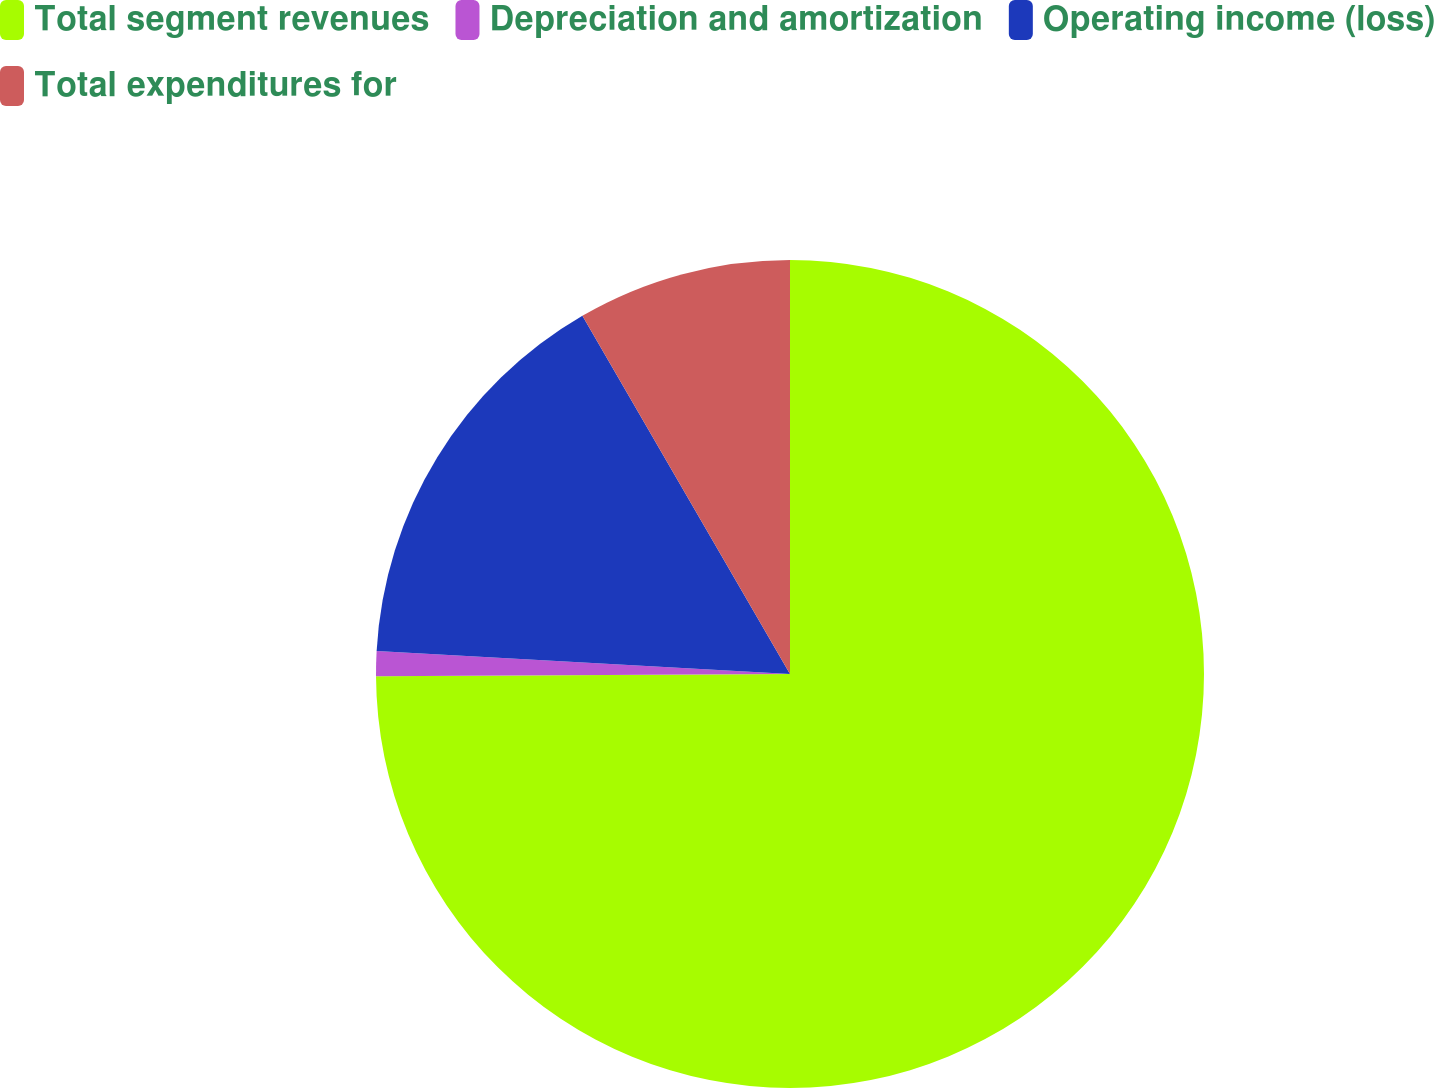Convert chart. <chart><loc_0><loc_0><loc_500><loc_500><pie_chart><fcel>Total segment revenues<fcel>Depreciation and amortization<fcel>Operating income (loss)<fcel>Total expenditures for<nl><fcel>74.91%<fcel>0.97%<fcel>15.76%<fcel>8.36%<nl></chart> 